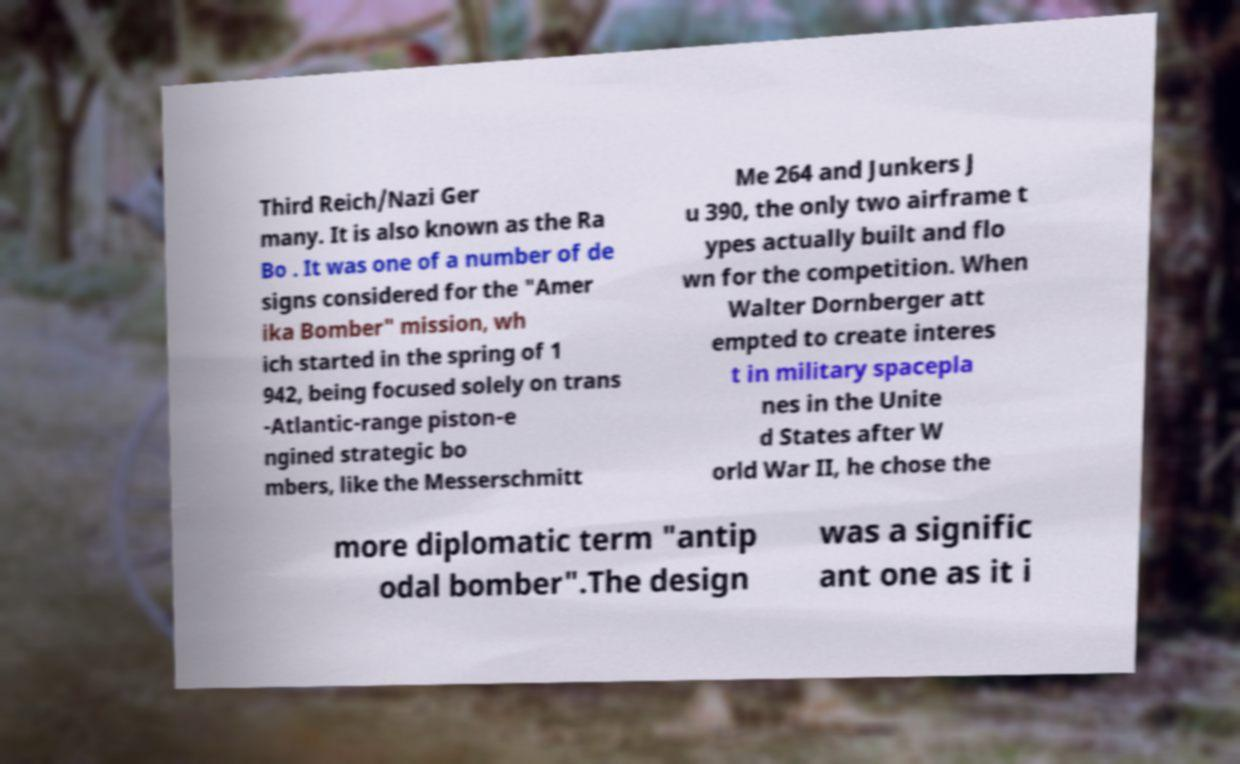Can you accurately transcribe the text from the provided image for me? Third Reich/Nazi Ger many. It is also known as the Ra Bo . It was one of a number of de signs considered for the "Amer ika Bomber" mission, wh ich started in the spring of 1 942, being focused solely on trans -Atlantic-range piston-e ngined strategic bo mbers, like the Messerschmitt Me 264 and Junkers J u 390, the only two airframe t ypes actually built and flo wn for the competition. When Walter Dornberger att empted to create interes t in military spacepla nes in the Unite d States after W orld War II, he chose the more diplomatic term "antip odal bomber".The design was a signific ant one as it i 